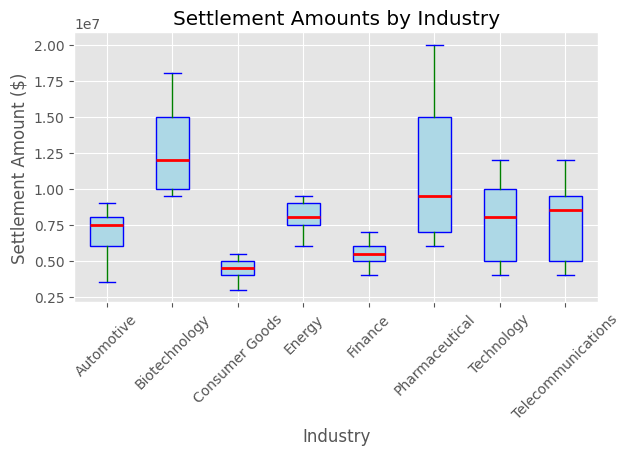What is the median settlement amount in the Technology industry? The boxplot shows that the median settlement amount is represented by the thick red line inside the box for each industry. For Technology, this line is at $8,000,000.
Answer: $8,000,000 Which industry has the highest maximum settlement amount? The maximum settlement amount is indicated by the top whisker of each boxplot. The Pharmaceutical industry's whisker reaches the highest at $20,000,000.
Answer: Pharmaceutical What is the interquartile range (IQR) for the Consumer Goods industry? The IQR is the distance between the top (75th percentile) and bottom (25th percentile) of the box. For Consumer Goods, the top of the box is at $5,000,000 and the bottom is at $4,000,000. So the IQR is $5,000,000 - $4,000,000.
Answer: $1,000,000 Which industry has a median settlement amount higher than the Technology industry? Comparing the median lines (red) across the industries, Biotechnology and Pharmaceutical have medians higher than Technology's $8,000,000.
Answer: Biotechnology and Pharmaceutical Is the median settlement amount in the Finance industry greater than the interquartile range of the Automotive industry? The median for Finance is shown by the red line at $5,500,000. For Automotive, the IQR is the range from $6,000,000 to $9,000,000, which is $3,000,000. $5,500,000 > $3,000,000.
Answer: Yes Which industries have median settlement amounts below $10,000,000? The red median lines below $10,000,000 are in Technology, Consumer Goods, Automotive, Energy, Finance, and Telecommunications.
Answer: Technology, Consumer Goods, Automotive, Energy, Finance, Telecommunications What is the range of settlement amounts in the Telecommunications industry? The range is the distance between the lowest (bottom whisker) and highest (top whisker) settlement amounts. For Telecommunications, this is from $4,000,000 to $12,000,000.
Answer: $8,000,000 Is the maximum settlement amount in the Automotive industry closer to its median or its minimum settlement amount? The Automotive industry's maximum is $9,000,000, its median is $7,500,000, and its minimum is $3,500,000. The distance between the maximum and median is $1,500,000, and between the maximum and minimum is $5,500,000.
Answer: Median Which industry has the smallest interquartile range? The smallest IQR is indicated by the shortest height of the box. The Consumer Goods industry has the smallest IQR at $1,000,000.
Answer: Consumer Goods 